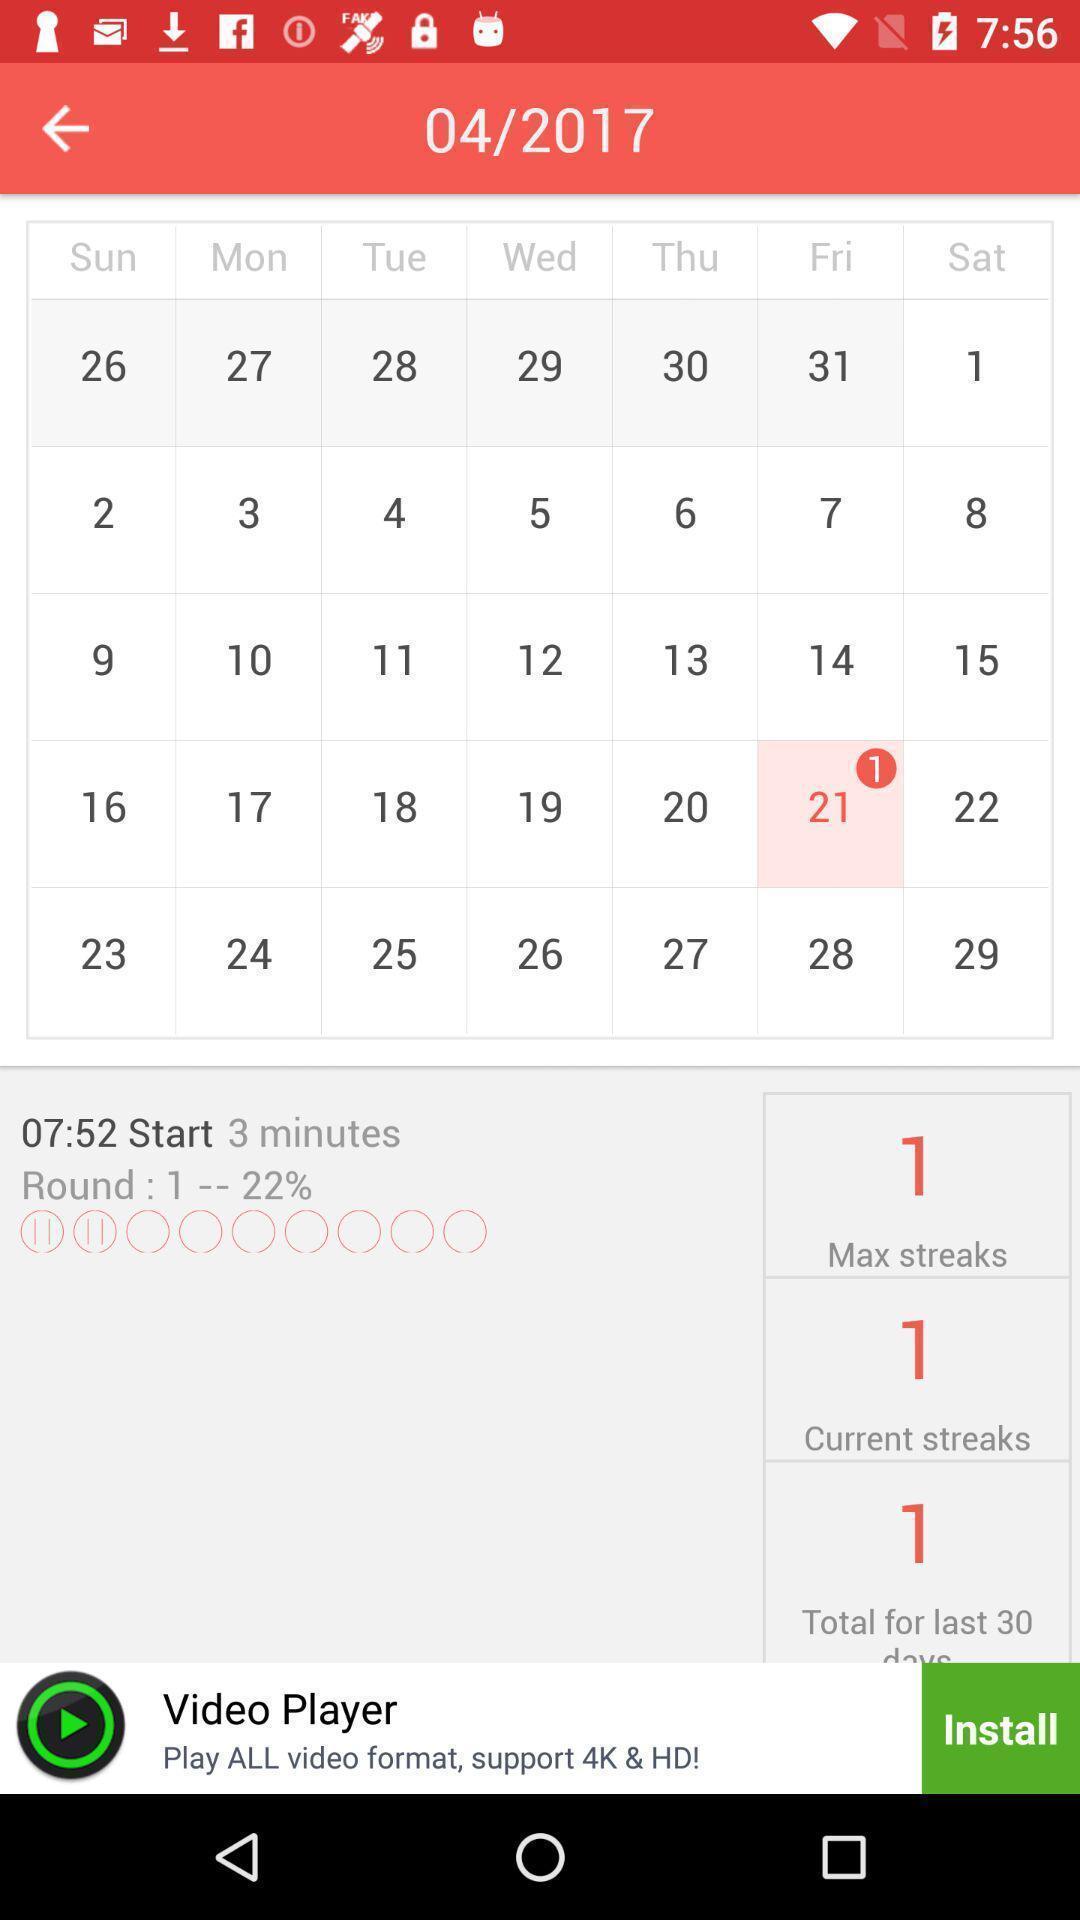Please provide a description for this image. Social app displaying monthly calendar. 